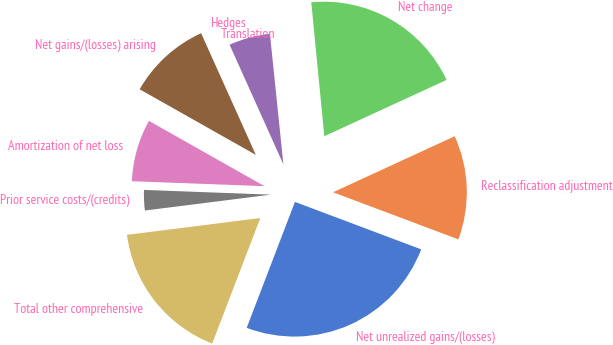Convert chart. <chart><loc_0><loc_0><loc_500><loc_500><pie_chart><fcel>Net unrealized gains/(losses)<fcel>Reclassification adjustment<fcel>Net change<fcel>Translation<fcel>Hedges<fcel>Net gains/(losses) arising<fcel>Amortization of net loss<fcel>Prior service costs/(credits)<fcel>Total other comprehensive<nl><fcel>25.1%<fcel>12.59%<fcel>19.68%<fcel>0.09%<fcel>5.09%<fcel>10.09%<fcel>7.59%<fcel>2.59%<fcel>17.18%<nl></chart> 